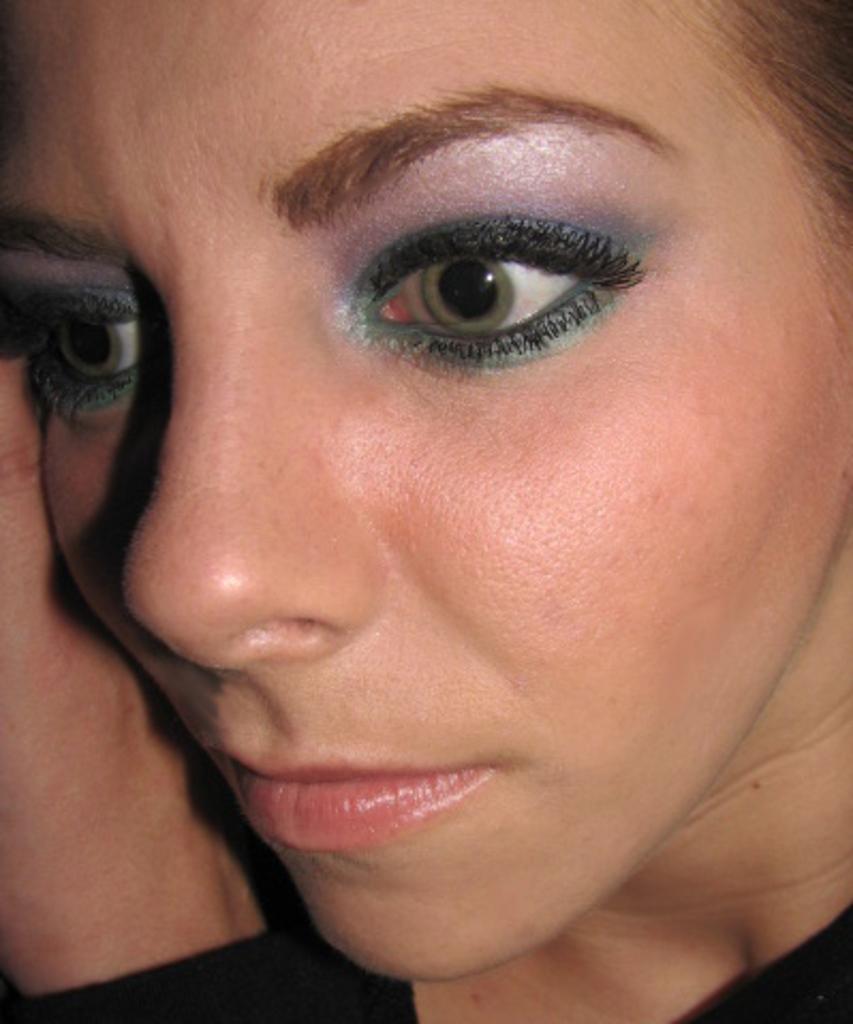Can you describe this image briefly? In the picture I can see a face of a woman. 